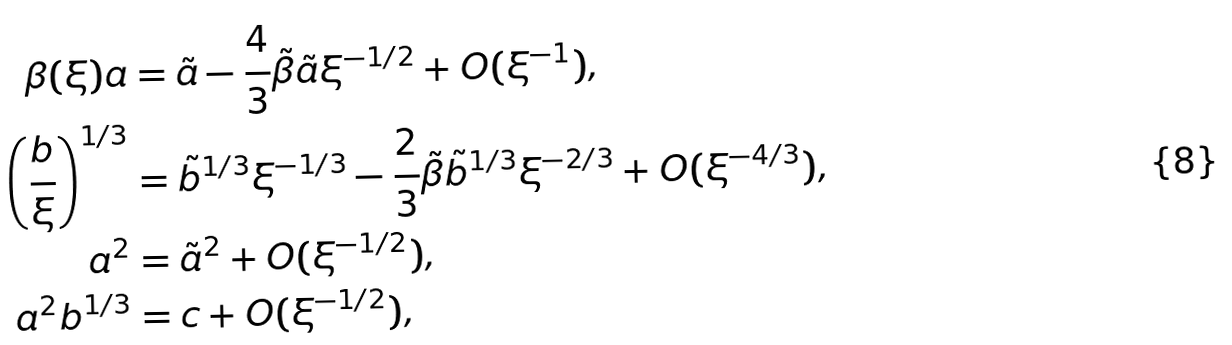<formula> <loc_0><loc_0><loc_500><loc_500>\beta ( \xi ) a & = \tilde { a } - \frac { 4 } { 3 } \tilde { \beta } \tilde { a } \xi ^ { - 1 / 2 } + O ( \xi ^ { - 1 } ) , \\ \left ( \frac { b } { \xi } \right ) ^ { 1 / 3 } & = \tilde { b } ^ { 1 / 3 } \xi ^ { - 1 / 3 } - \frac { 2 } { 3 } \tilde { \beta } \tilde { b } ^ { 1 / 3 } \xi ^ { - 2 / 3 } + O ( \xi ^ { - 4 / 3 } ) , \\ a ^ { 2 } & = \tilde { a } ^ { 2 } + O ( \xi ^ { - 1 / 2 } ) , \\ a ^ { 2 } b ^ { 1 / 3 } & = c + O ( \xi ^ { - 1 / 2 } ) ,</formula> 